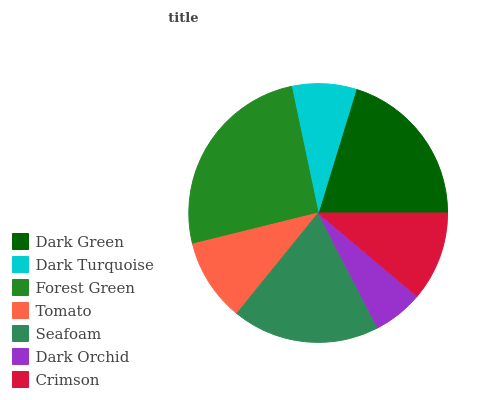Is Dark Orchid the minimum?
Answer yes or no. Yes. Is Forest Green the maximum?
Answer yes or no. Yes. Is Dark Turquoise the minimum?
Answer yes or no. No. Is Dark Turquoise the maximum?
Answer yes or no. No. Is Dark Green greater than Dark Turquoise?
Answer yes or no. Yes. Is Dark Turquoise less than Dark Green?
Answer yes or no. Yes. Is Dark Turquoise greater than Dark Green?
Answer yes or no. No. Is Dark Green less than Dark Turquoise?
Answer yes or no. No. Is Crimson the high median?
Answer yes or no. Yes. Is Crimson the low median?
Answer yes or no. Yes. Is Tomato the high median?
Answer yes or no. No. Is Seafoam the low median?
Answer yes or no. No. 